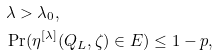<formula> <loc_0><loc_0><loc_500><loc_500>& \lambda > \lambda _ { 0 } , \\ & \Pr ( \eta ^ { [ \lambda ] } ( Q _ { L } , \zeta ) \in E ) \leq 1 - p ,</formula> 